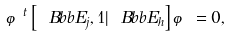Convert formula to latex. <formula><loc_0><loc_0><loc_500><loc_500>\varphi ^ { t } \left [ { \ B b b E } _ { j } , 1 | { \ B b b E } _ { h } \right ] \varphi = 0 ,</formula> 